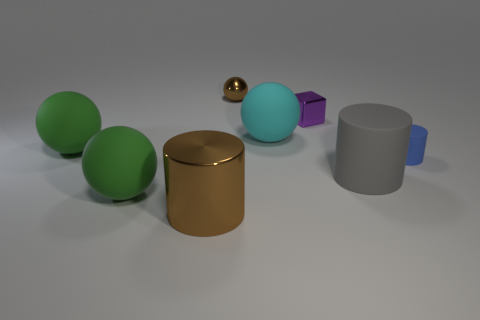What size is the blue matte thing that is the same shape as the large brown shiny thing?
Your answer should be very brief. Small. What number of brown things are behind the big shiny cylinder and in front of the small metal block?
Give a very brief answer. 0. Do the large brown thing and the brown object that is behind the cube have the same shape?
Give a very brief answer. No. Are there more blue things that are on the left side of the large cyan matte sphere than large red metallic cylinders?
Your answer should be very brief. No. Are there fewer tiny brown things right of the small metallic sphere than gray matte objects?
Provide a succinct answer. Yes. How many spheres have the same color as the big rubber cylinder?
Your response must be concise. 0. What material is the thing that is both on the right side of the cyan ball and to the left of the gray thing?
Make the answer very short. Metal. There is a large cylinder right of the cyan thing; is it the same color as the big matte object that is in front of the gray thing?
Provide a short and direct response. No. What number of blue things are either big cylinders or tiny spheres?
Give a very brief answer. 0. Are there fewer tiny rubber objects that are on the left side of the tiny purple block than small purple objects on the right side of the large gray matte cylinder?
Your response must be concise. No. 